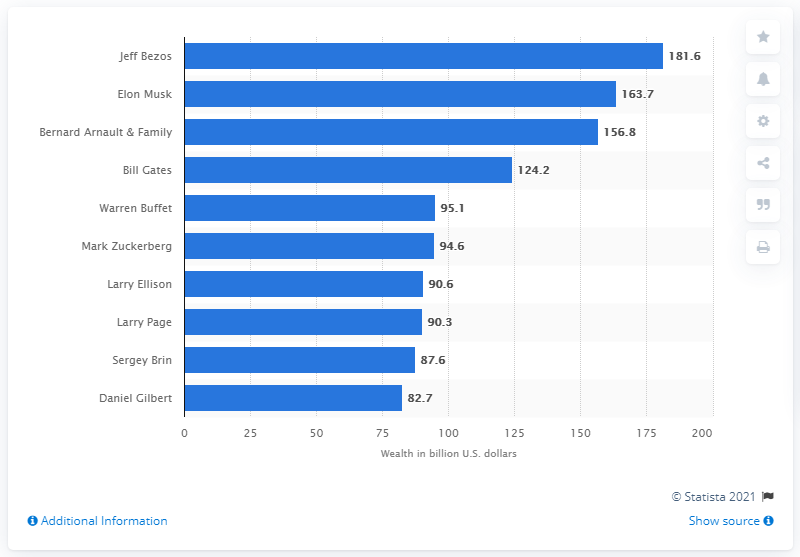Outline some significant characteristics in this image. In 2021, Jeff Bezos was considered the wealthiest person. In 2021, Elon Musk was considered the wealthiest person in the world. 